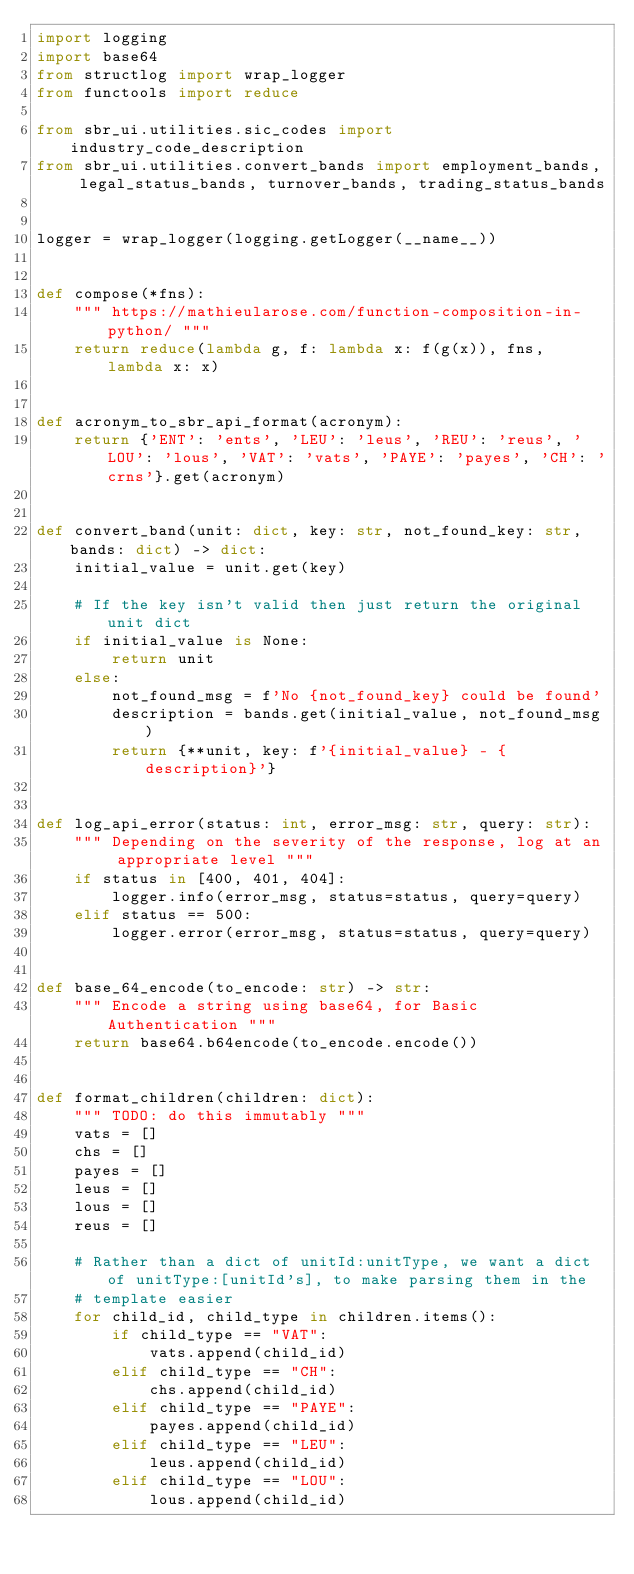<code> <loc_0><loc_0><loc_500><loc_500><_Python_>import logging
import base64
from structlog import wrap_logger
from functools import reduce

from sbr_ui.utilities.sic_codes import industry_code_description
from sbr_ui.utilities.convert_bands import employment_bands, legal_status_bands, turnover_bands, trading_status_bands


logger = wrap_logger(logging.getLogger(__name__))


def compose(*fns):
    """ https://mathieularose.com/function-composition-in-python/ """
    return reduce(lambda g, f: lambda x: f(g(x)), fns, lambda x: x)


def acronym_to_sbr_api_format(acronym):
    return {'ENT': 'ents', 'LEU': 'leus', 'REU': 'reus', 'LOU': 'lous', 'VAT': 'vats', 'PAYE': 'payes', 'CH': 'crns'}.get(acronym)


def convert_band(unit: dict, key: str, not_found_key: str, bands: dict) -> dict:
    initial_value = unit.get(key)

    # If the key isn't valid then just return the original unit dict
    if initial_value is None:
        return unit
    else:
        not_found_msg = f'No {not_found_key} could be found'
        description = bands.get(initial_value, not_found_msg)
        return {**unit, key: f'{initial_value} - {description}'}


def log_api_error(status: int, error_msg: str, query: str):
    """ Depending on the severity of the response, log at an appropriate level """
    if status in [400, 401, 404]:
        logger.info(error_msg, status=status, query=query)
    elif status == 500:
        logger.error(error_msg, status=status, query=query)


def base_64_encode(to_encode: str) -> str:
    """ Encode a string using base64, for Basic Authentication """
    return base64.b64encode(to_encode.encode())


def format_children(children: dict):
    """ TODO: do this immutably """
    vats = []
    chs = []
    payes = []
    leus = []
    lous = []
    reus = []

    # Rather than a dict of unitId:unitType, we want a dict of unitType:[unitId's], to make parsing them in the
    # template easier
    for child_id, child_type in children.items():
        if child_type == "VAT":
            vats.append(child_id)
        elif child_type == "CH":
            chs.append(child_id)
        elif child_type == "PAYE":
            payes.append(child_id)
        elif child_type == "LEU":
            leus.append(child_id)
        elif child_type == "LOU":
            lous.append(child_id)</code> 